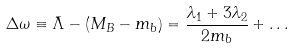<formula> <loc_0><loc_0><loc_500><loc_500>\Delta \omega \equiv \bar { \Lambda } - ( M _ { B } - m _ { b } ) = \frac { \lambda _ { 1 } + 3 \lambda _ { 2 } } { 2 m _ { b } } + \dots</formula> 